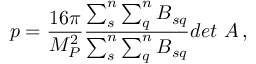<formula> <loc_0><loc_0><loc_500><loc_500>p = \frac { 1 6 \pi } { M _ { P } ^ { 2 } } \frac { \sum _ { s } ^ { n } \sum _ { q } ^ { n } B _ { s q } } { \sum _ { s } ^ { n } \sum _ { q } ^ { n } B _ { s q } } { d e t A } \, ,</formula> 